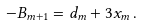<formula> <loc_0><loc_0><loc_500><loc_500>- B _ { m + 1 } = d _ { m } + 3 x _ { m } \, .</formula> 